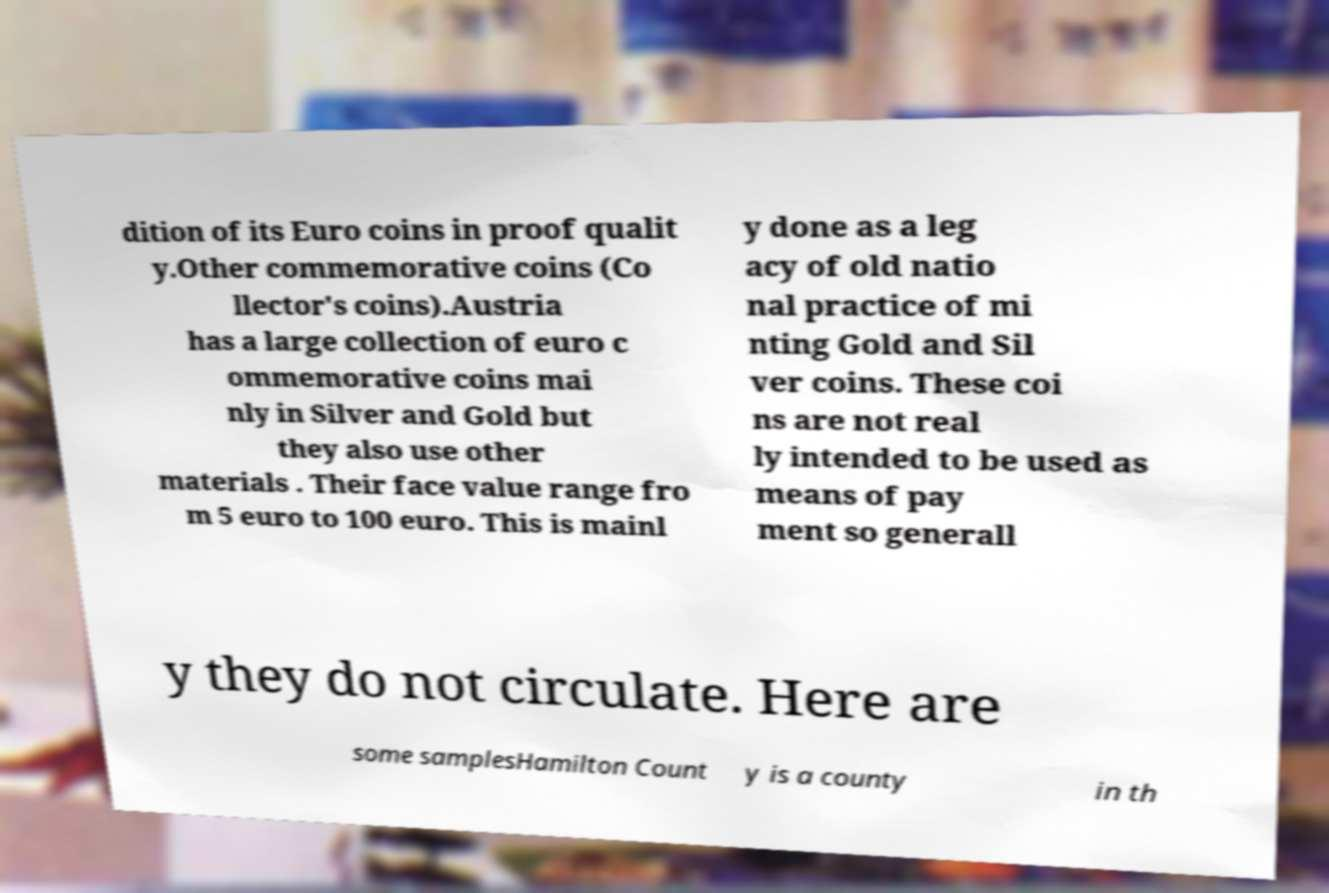There's text embedded in this image that I need extracted. Can you transcribe it verbatim? dition of its Euro coins in proof qualit y.Other commemorative coins (Co llector's coins).Austria has a large collection of euro c ommemorative coins mai nly in Silver and Gold but they also use other materials . Their face value range fro m 5 euro to 100 euro. This is mainl y done as a leg acy of old natio nal practice of mi nting Gold and Sil ver coins. These coi ns are not real ly intended to be used as means of pay ment so generall y they do not circulate. Here are some samplesHamilton Count y is a county in th 